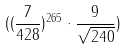<formula> <loc_0><loc_0><loc_500><loc_500>( ( \frac { 7 } { 4 2 8 } ) ^ { 2 6 5 } \cdot \frac { 9 } { \sqrt { 2 4 0 } } )</formula> 